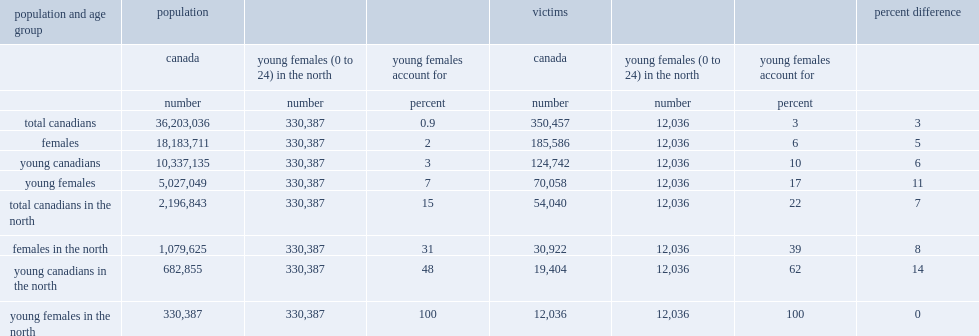Would you be able to parse every entry in this table? {'header': ['population and age group', 'population', '', '', 'victims', '', '', 'percent difference'], 'rows': [['', 'canada', 'young females (0 to 24) in the north', 'young females account for', 'canada', 'young females (0 to 24) in the north', 'young females account for', ''], ['', 'number', 'number', 'percent', 'number', 'number', 'percent', ''], ['total canadians', '36,203,036', '330,387', '0.9', '350,457', '12,036', '3', '3'], ['females', '18,183,711', '330,387', '2', '185,586', '12,036', '6', '5'], ['young canadians', '10,337,135', '330,387', '3', '124,742', '12,036', '10', '6'], ['young females', '5,027,049', '330,387', '7', '70,058', '12,036', '17', '11'], ['total canadians in the north', '2,196,843', '330,387', '15', '54,040', '12,036', '22', '7'], ['females in the north', '1,079,625', '330,387', '31', '30,922', '12,036', '39', '8'], ['young canadians in the north', '682,855', '330,387', '48', '19,404', '12,036', '62', '14'], ['young females in the north', '330,387', '330,387', '100', '12,036', '12,036', '100', '0']]} In the north, how many percentage points did females account for of the population aged 24 and younger? 48.0. In the north, how many percentage points did females account for of victims of violent crime aged 24 and younger? 62.0. 